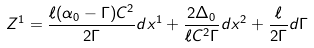<formula> <loc_0><loc_0><loc_500><loc_500>Z ^ { 1 } = \frac { \ell ( \alpha _ { 0 } - \Gamma ) C ^ { 2 } } { 2 \Gamma } d x ^ { 1 } + \frac { 2 \Delta _ { 0 } } { \ell C ^ { 2 } \Gamma } d x ^ { 2 } + \frac { \ell } { 2 \Gamma } d \Gamma</formula> 